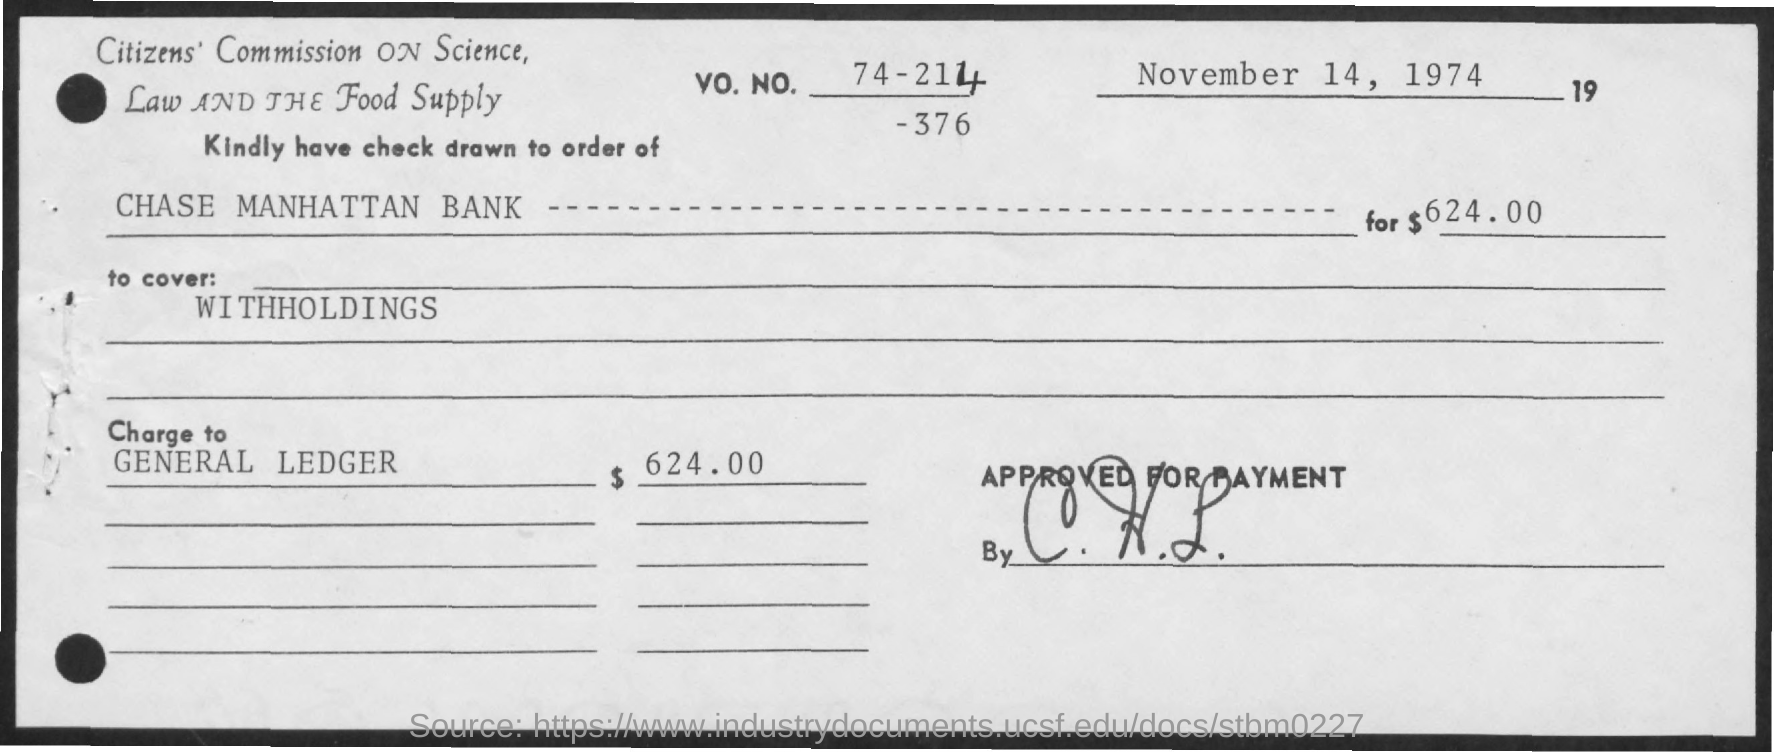What amount is charged to general ledger?
Provide a succinct answer. 624.00. What is date mentioned
Your answer should be very brief. November 14, 1974. 